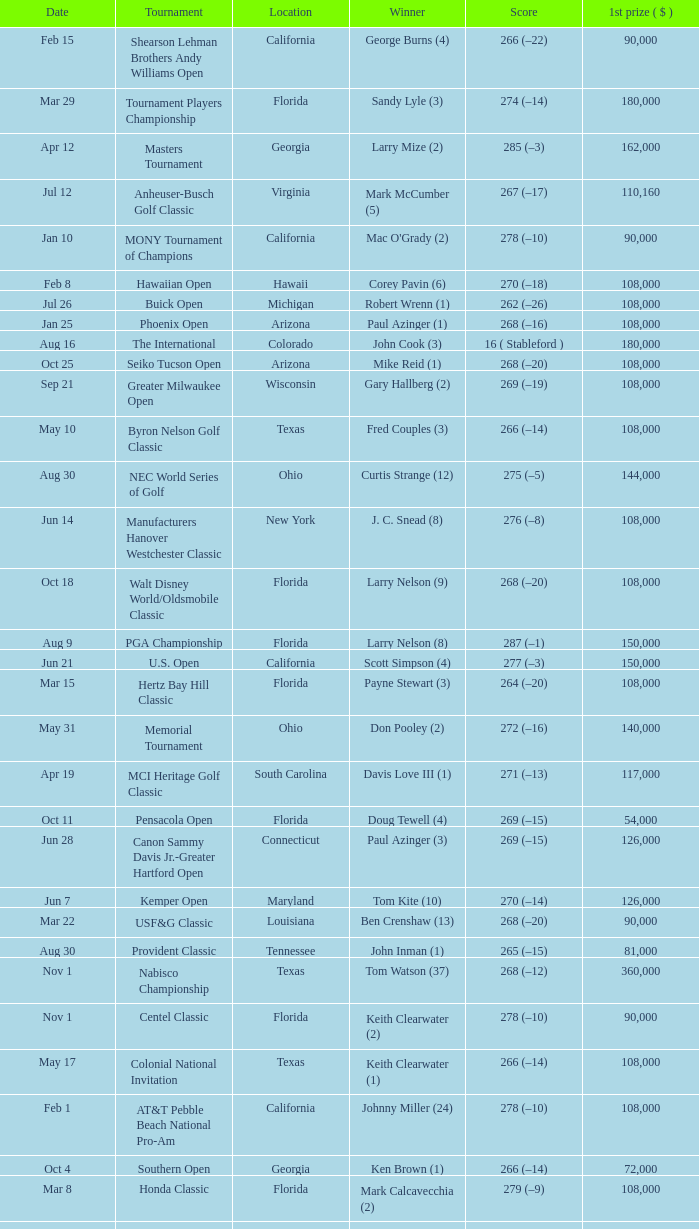What is the score from the winner Keith Clearwater (1)? 266 (–14). 